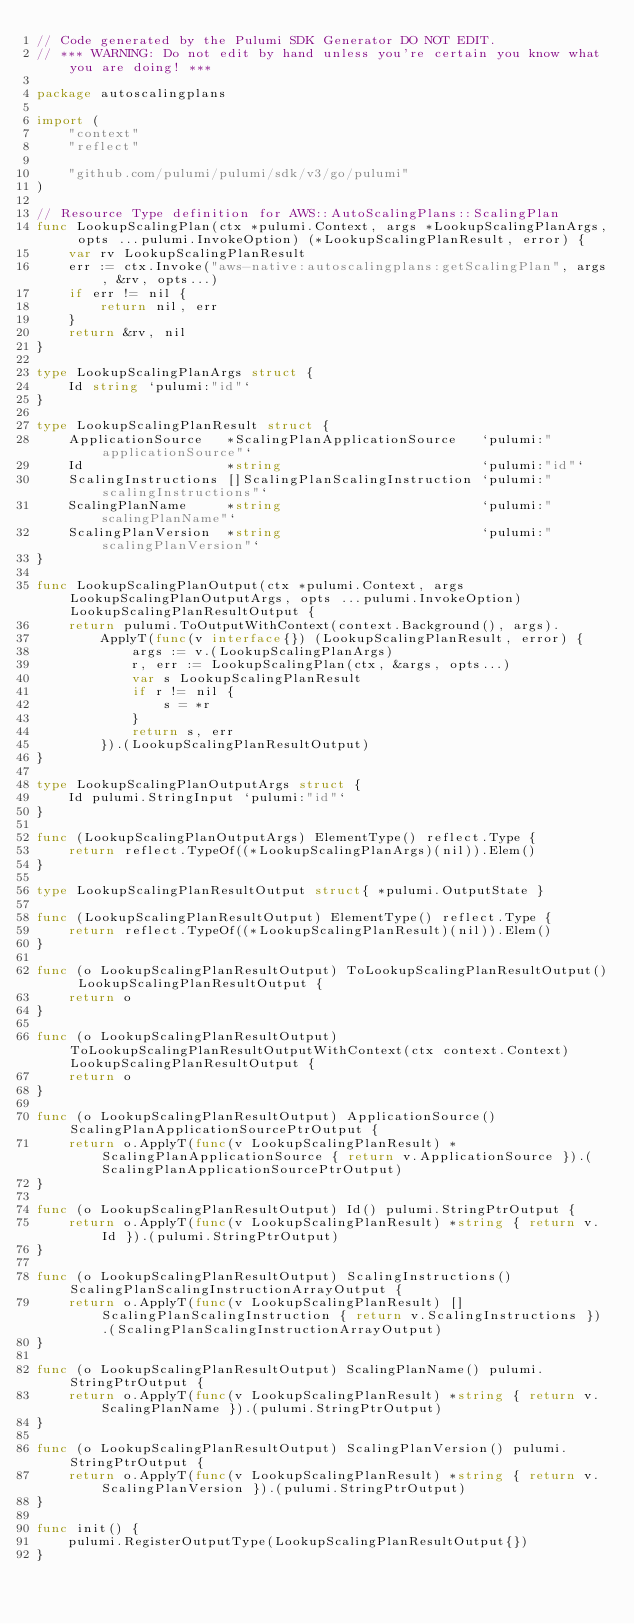Convert code to text. <code><loc_0><loc_0><loc_500><loc_500><_Go_>// Code generated by the Pulumi SDK Generator DO NOT EDIT.
// *** WARNING: Do not edit by hand unless you're certain you know what you are doing! ***

package autoscalingplans

import (
	"context"
	"reflect"

	"github.com/pulumi/pulumi/sdk/v3/go/pulumi"
)

// Resource Type definition for AWS::AutoScalingPlans::ScalingPlan
func LookupScalingPlan(ctx *pulumi.Context, args *LookupScalingPlanArgs, opts ...pulumi.InvokeOption) (*LookupScalingPlanResult, error) {
	var rv LookupScalingPlanResult
	err := ctx.Invoke("aws-native:autoscalingplans:getScalingPlan", args, &rv, opts...)
	if err != nil {
		return nil, err
	}
	return &rv, nil
}

type LookupScalingPlanArgs struct {
	Id string `pulumi:"id"`
}

type LookupScalingPlanResult struct {
	ApplicationSource   *ScalingPlanApplicationSource   `pulumi:"applicationSource"`
	Id                  *string                         `pulumi:"id"`
	ScalingInstructions []ScalingPlanScalingInstruction `pulumi:"scalingInstructions"`
	ScalingPlanName     *string                         `pulumi:"scalingPlanName"`
	ScalingPlanVersion  *string                         `pulumi:"scalingPlanVersion"`
}

func LookupScalingPlanOutput(ctx *pulumi.Context, args LookupScalingPlanOutputArgs, opts ...pulumi.InvokeOption) LookupScalingPlanResultOutput {
	return pulumi.ToOutputWithContext(context.Background(), args).
		ApplyT(func(v interface{}) (LookupScalingPlanResult, error) {
			args := v.(LookupScalingPlanArgs)
			r, err := LookupScalingPlan(ctx, &args, opts...)
			var s LookupScalingPlanResult
			if r != nil {
				s = *r
			}
			return s, err
		}).(LookupScalingPlanResultOutput)
}

type LookupScalingPlanOutputArgs struct {
	Id pulumi.StringInput `pulumi:"id"`
}

func (LookupScalingPlanOutputArgs) ElementType() reflect.Type {
	return reflect.TypeOf((*LookupScalingPlanArgs)(nil)).Elem()
}

type LookupScalingPlanResultOutput struct{ *pulumi.OutputState }

func (LookupScalingPlanResultOutput) ElementType() reflect.Type {
	return reflect.TypeOf((*LookupScalingPlanResult)(nil)).Elem()
}

func (o LookupScalingPlanResultOutput) ToLookupScalingPlanResultOutput() LookupScalingPlanResultOutput {
	return o
}

func (o LookupScalingPlanResultOutput) ToLookupScalingPlanResultOutputWithContext(ctx context.Context) LookupScalingPlanResultOutput {
	return o
}

func (o LookupScalingPlanResultOutput) ApplicationSource() ScalingPlanApplicationSourcePtrOutput {
	return o.ApplyT(func(v LookupScalingPlanResult) *ScalingPlanApplicationSource { return v.ApplicationSource }).(ScalingPlanApplicationSourcePtrOutput)
}

func (o LookupScalingPlanResultOutput) Id() pulumi.StringPtrOutput {
	return o.ApplyT(func(v LookupScalingPlanResult) *string { return v.Id }).(pulumi.StringPtrOutput)
}

func (o LookupScalingPlanResultOutput) ScalingInstructions() ScalingPlanScalingInstructionArrayOutput {
	return o.ApplyT(func(v LookupScalingPlanResult) []ScalingPlanScalingInstruction { return v.ScalingInstructions }).(ScalingPlanScalingInstructionArrayOutput)
}

func (o LookupScalingPlanResultOutput) ScalingPlanName() pulumi.StringPtrOutput {
	return o.ApplyT(func(v LookupScalingPlanResult) *string { return v.ScalingPlanName }).(pulumi.StringPtrOutput)
}

func (o LookupScalingPlanResultOutput) ScalingPlanVersion() pulumi.StringPtrOutput {
	return o.ApplyT(func(v LookupScalingPlanResult) *string { return v.ScalingPlanVersion }).(pulumi.StringPtrOutput)
}

func init() {
	pulumi.RegisterOutputType(LookupScalingPlanResultOutput{})
}
</code> 